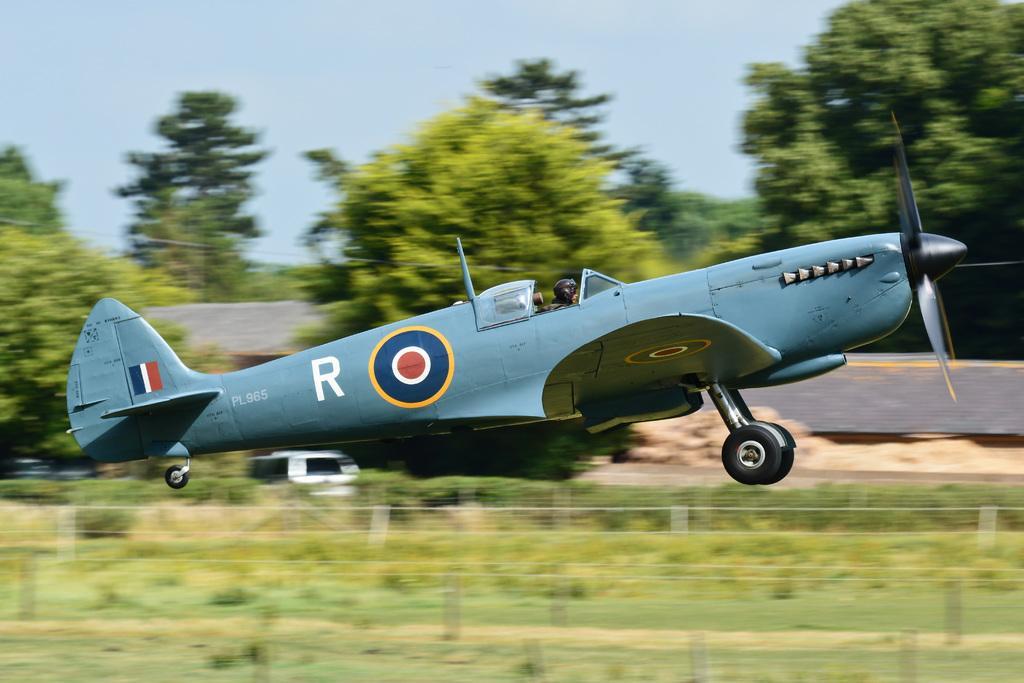In one or two sentences, can you explain what this image depicts? In this picture we can see an airplane flying in the air, grass, trees and in the background we can see the sky. 